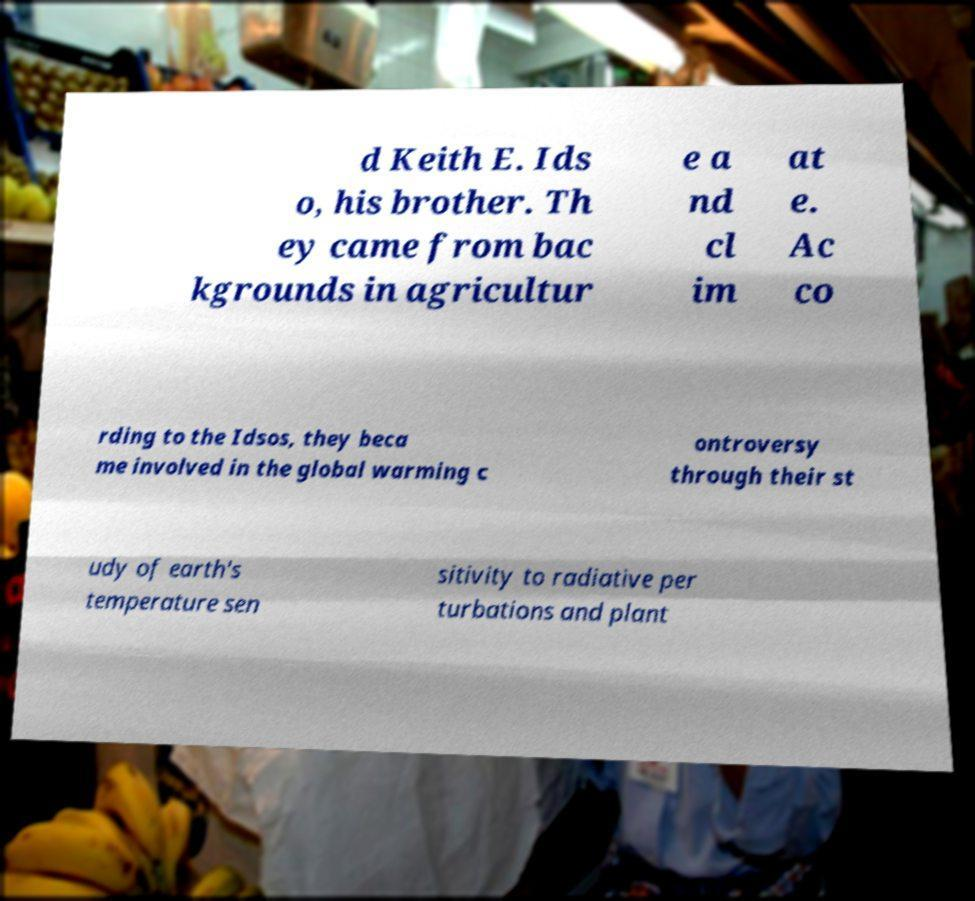For documentation purposes, I need the text within this image transcribed. Could you provide that? d Keith E. Ids o, his brother. Th ey came from bac kgrounds in agricultur e a nd cl im at e. Ac co rding to the Idsos, they beca me involved in the global warming c ontroversy through their st udy of earth's temperature sen sitivity to radiative per turbations and plant 